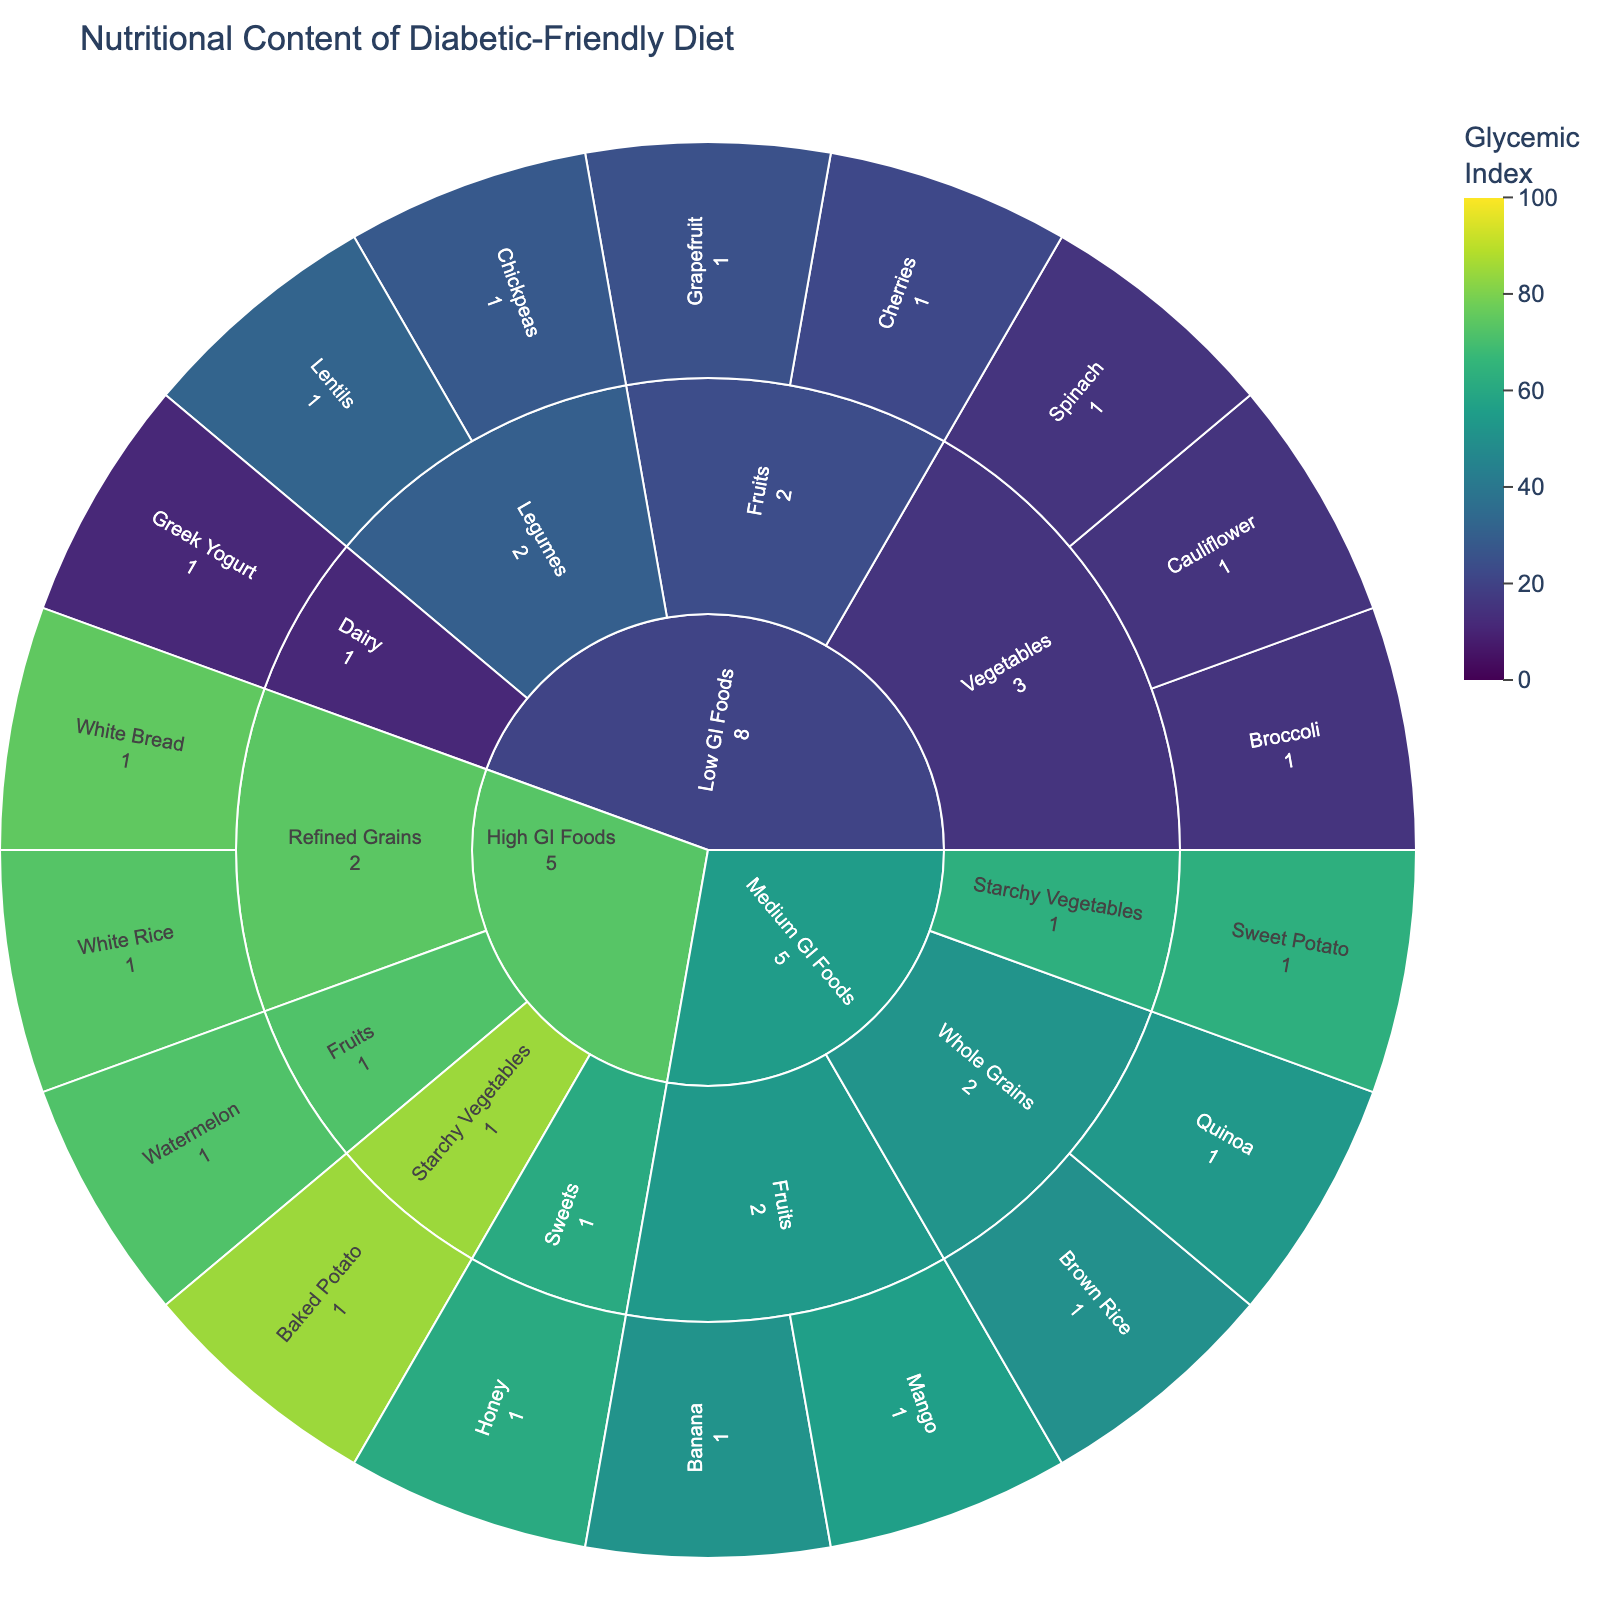What's the title displayed at the top of the figure? The title is found at the top of the sunburst plot and provides an overview of what the plot represents.
Answer: Nutritional Content of Diabetic-Friendly Diet How many food groups are there in the 'Low GI Foods' category? Locate the 'Low GI Foods' section in the sunburst plot and count the different food groups under this category (Vegetables, Fruits, Legumes, Dairy).
Answer: 4 Which food group has the highest glycemic index in the 'Medium GI Foods' category? Find the 'Medium GI Foods' section and compare the glycemic index values of all food groups within this category. Starchy Vegetables have a higher glycemic index compared to Whole Grains and Fruits.
Answer: Starchy Vegetables (63) What is the portion size of Greek Yogurt in the 'Low GI Foods' category? Go to the 'Low GI Foods' category in the plot, locate Greek Yogurt under Dairy, and identify the portion size mentioned.
Answer: 150 grams Which food item in the 'High GI Foods' category has the highest glycemic index? Navigate to the 'High GI Foods' section and examine the glycemic index values of each food item. Baked Potato has a glycemic index of 85.
Answer: Baked Potato How does the glycemic index of White Bread compare to White Rice? Check the 'High GI Foods' category for both White Bread and White Rice, then compare their glycemic index values.
Answer: White Bread (75) is higher than White Rice (73) What's the total number of food items in the 'High GI Foods' category? In the 'High GI Foods' section, count all food items listed (Refined Grains, Sweets, Fruits, Starchy Vegetables).
Answer: 5 Which has a lower glycemic index, Mango or Banana? Look under the 'Medium GI Foods' category and compare the glycemic index values of Mango (56) and Banana (51).
Answer: Banana (51) If you combine the portion sizes of Lentils and Chickpeas from the 'Low GI Foods' category, what is the total portion size? Both Lentils and Chickpeas are under the Legumes in 'Low GI Foods.' Sum their portions: 150 grams + 150 grams = 300 grams.
Answer: 300 grams Which category contains foods with the lowest glycemic index values? Compare the lowest glycemic index values across all categories. The 'Low GI Foods' category contains foods with the lowest glycemic index values (e.g., Greek Yogurt with a glycemic index of 11).
Answer: Low GI Foods 